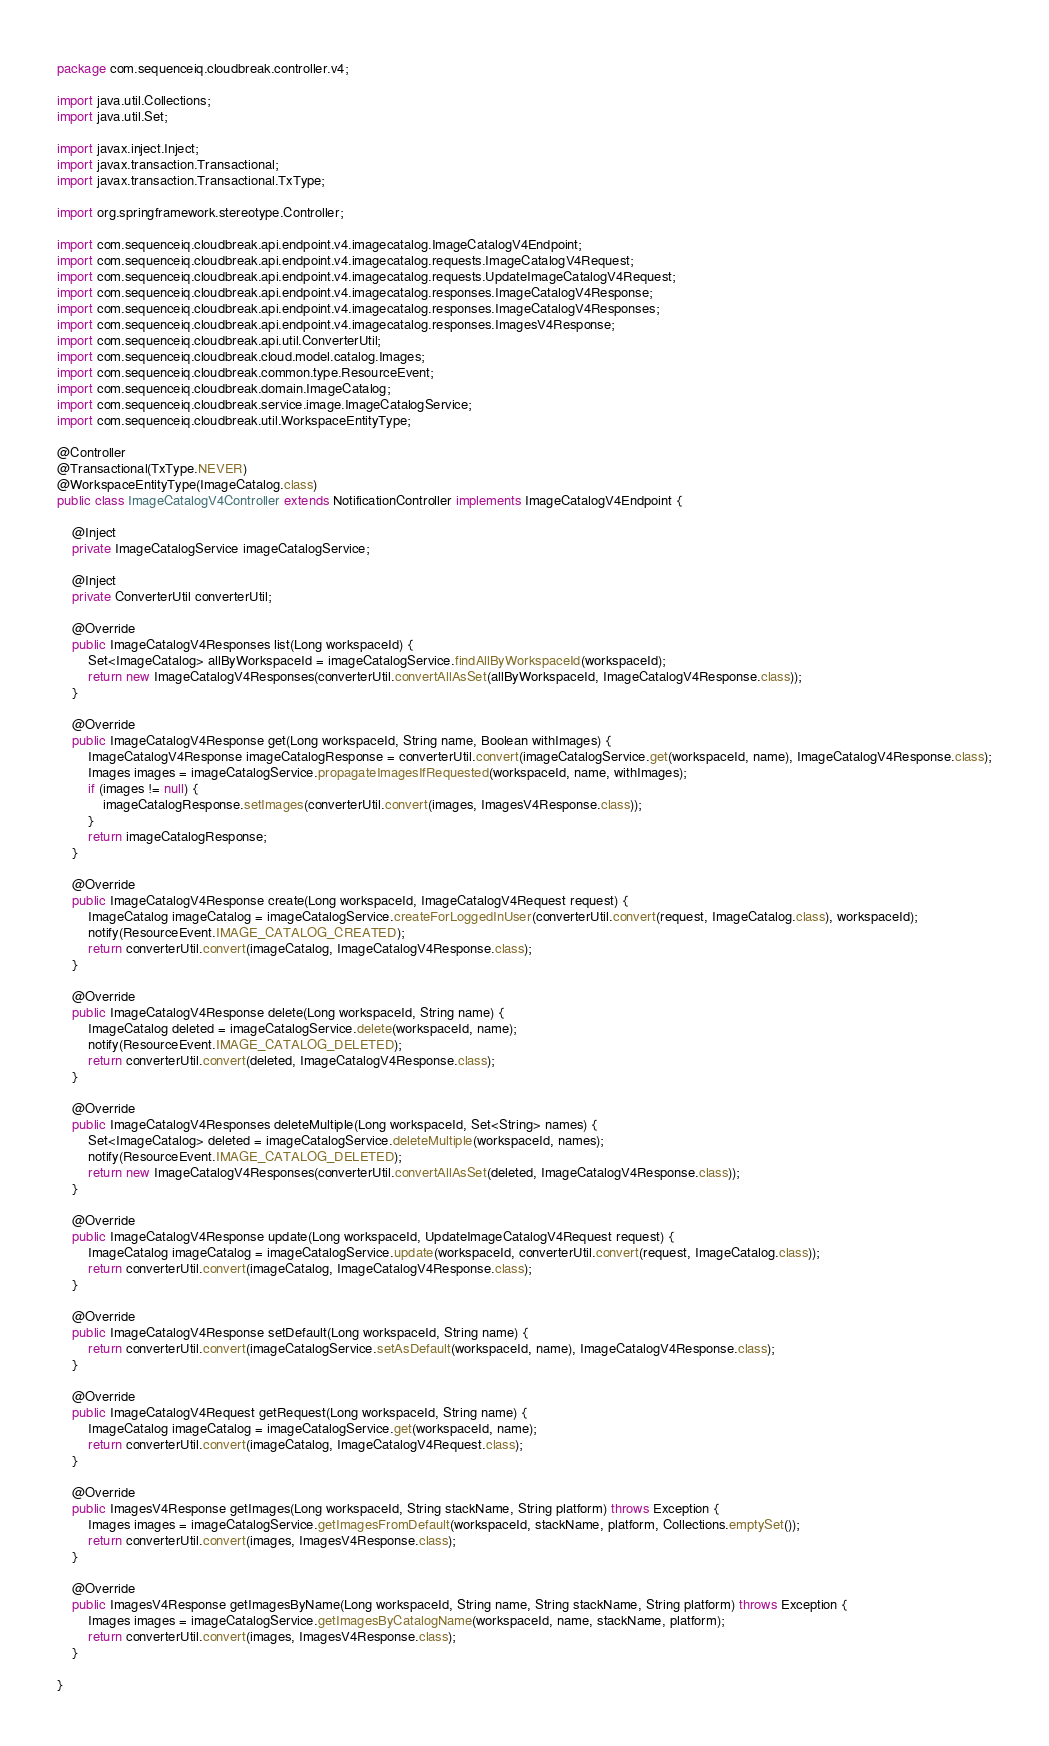Convert code to text. <code><loc_0><loc_0><loc_500><loc_500><_Java_>package com.sequenceiq.cloudbreak.controller.v4;

import java.util.Collections;
import java.util.Set;

import javax.inject.Inject;
import javax.transaction.Transactional;
import javax.transaction.Transactional.TxType;

import org.springframework.stereotype.Controller;

import com.sequenceiq.cloudbreak.api.endpoint.v4.imagecatalog.ImageCatalogV4Endpoint;
import com.sequenceiq.cloudbreak.api.endpoint.v4.imagecatalog.requests.ImageCatalogV4Request;
import com.sequenceiq.cloudbreak.api.endpoint.v4.imagecatalog.requests.UpdateImageCatalogV4Request;
import com.sequenceiq.cloudbreak.api.endpoint.v4.imagecatalog.responses.ImageCatalogV4Response;
import com.sequenceiq.cloudbreak.api.endpoint.v4.imagecatalog.responses.ImageCatalogV4Responses;
import com.sequenceiq.cloudbreak.api.endpoint.v4.imagecatalog.responses.ImagesV4Response;
import com.sequenceiq.cloudbreak.api.util.ConverterUtil;
import com.sequenceiq.cloudbreak.cloud.model.catalog.Images;
import com.sequenceiq.cloudbreak.common.type.ResourceEvent;
import com.sequenceiq.cloudbreak.domain.ImageCatalog;
import com.sequenceiq.cloudbreak.service.image.ImageCatalogService;
import com.sequenceiq.cloudbreak.util.WorkspaceEntityType;

@Controller
@Transactional(TxType.NEVER)
@WorkspaceEntityType(ImageCatalog.class)
public class ImageCatalogV4Controller extends NotificationController implements ImageCatalogV4Endpoint {

    @Inject
    private ImageCatalogService imageCatalogService;

    @Inject
    private ConverterUtil converterUtil;

    @Override
    public ImageCatalogV4Responses list(Long workspaceId) {
        Set<ImageCatalog> allByWorkspaceId = imageCatalogService.findAllByWorkspaceId(workspaceId);
        return new ImageCatalogV4Responses(converterUtil.convertAllAsSet(allByWorkspaceId, ImageCatalogV4Response.class));
    }

    @Override
    public ImageCatalogV4Response get(Long workspaceId, String name, Boolean withImages) {
        ImageCatalogV4Response imageCatalogResponse = converterUtil.convert(imageCatalogService.get(workspaceId, name), ImageCatalogV4Response.class);
        Images images = imageCatalogService.propagateImagesIfRequested(workspaceId, name, withImages);
        if (images != null) {
            imageCatalogResponse.setImages(converterUtil.convert(images, ImagesV4Response.class));
        }
        return imageCatalogResponse;
    }

    @Override
    public ImageCatalogV4Response create(Long workspaceId, ImageCatalogV4Request request) {
        ImageCatalog imageCatalog = imageCatalogService.createForLoggedInUser(converterUtil.convert(request, ImageCatalog.class), workspaceId);
        notify(ResourceEvent.IMAGE_CATALOG_CREATED);
        return converterUtil.convert(imageCatalog, ImageCatalogV4Response.class);
    }

    @Override
    public ImageCatalogV4Response delete(Long workspaceId, String name) {
        ImageCatalog deleted = imageCatalogService.delete(workspaceId, name);
        notify(ResourceEvent.IMAGE_CATALOG_DELETED);
        return converterUtil.convert(deleted, ImageCatalogV4Response.class);
    }

    @Override
    public ImageCatalogV4Responses deleteMultiple(Long workspaceId, Set<String> names) {
        Set<ImageCatalog> deleted = imageCatalogService.deleteMultiple(workspaceId, names);
        notify(ResourceEvent.IMAGE_CATALOG_DELETED);
        return new ImageCatalogV4Responses(converterUtil.convertAllAsSet(deleted, ImageCatalogV4Response.class));
    }

    @Override
    public ImageCatalogV4Response update(Long workspaceId, UpdateImageCatalogV4Request request) {
        ImageCatalog imageCatalog = imageCatalogService.update(workspaceId, converterUtil.convert(request, ImageCatalog.class));
        return converterUtil.convert(imageCatalog, ImageCatalogV4Response.class);
    }

    @Override
    public ImageCatalogV4Response setDefault(Long workspaceId, String name) {
        return converterUtil.convert(imageCatalogService.setAsDefault(workspaceId, name), ImageCatalogV4Response.class);
    }

    @Override
    public ImageCatalogV4Request getRequest(Long workspaceId, String name) {
        ImageCatalog imageCatalog = imageCatalogService.get(workspaceId, name);
        return converterUtil.convert(imageCatalog, ImageCatalogV4Request.class);
    }

    @Override
    public ImagesV4Response getImages(Long workspaceId, String stackName, String platform) throws Exception {
        Images images = imageCatalogService.getImagesFromDefault(workspaceId, stackName, platform, Collections.emptySet());
        return converterUtil.convert(images, ImagesV4Response.class);
    }

    @Override
    public ImagesV4Response getImagesByName(Long workspaceId, String name, String stackName, String platform) throws Exception {
        Images images = imageCatalogService.getImagesByCatalogName(workspaceId, name, stackName, platform);
        return converterUtil.convert(images, ImagesV4Response.class);
    }

}
</code> 